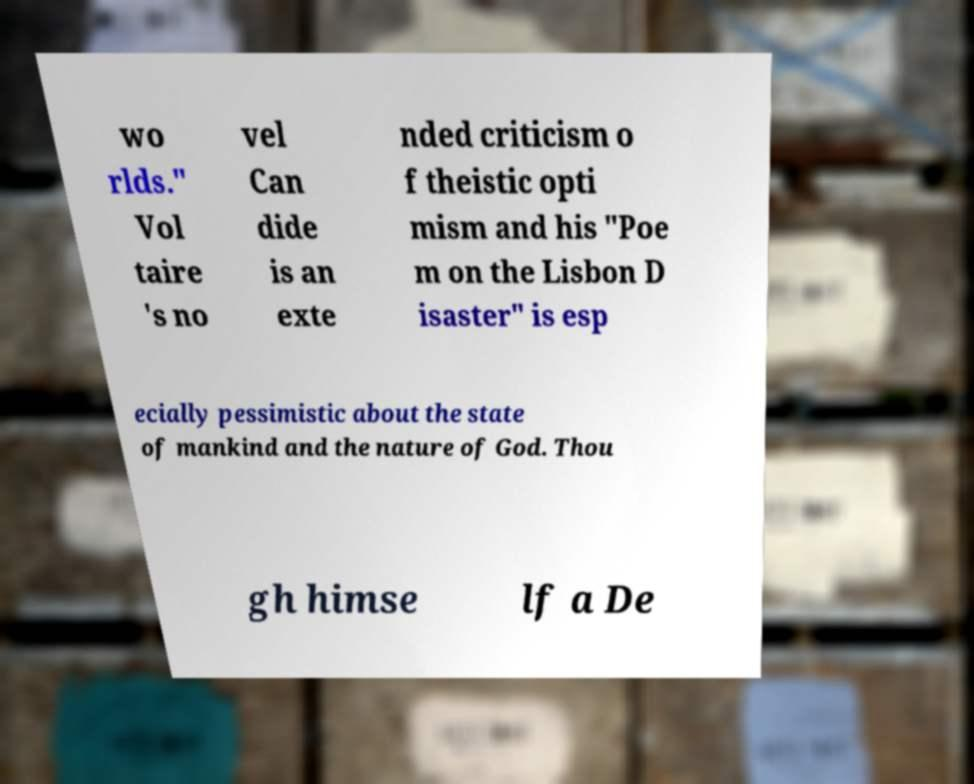Please identify and transcribe the text found in this image. wo rlds." Vol taire 's no vel Can dide is an exte nded criticism o f theistic opti mism and his "Poe m on the Lisbon D isaster" is esp ecially pessimistic about the state of mankind and the nature of God. Thou gh himse lf a De 